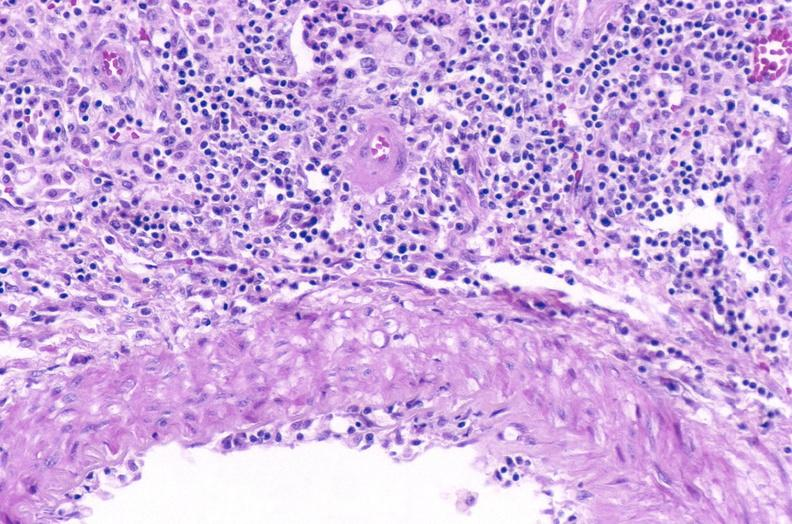does no tissue recognizable as ovary show kidney, acute transplant rejection?
Answer the question using a single word or phrase. No 